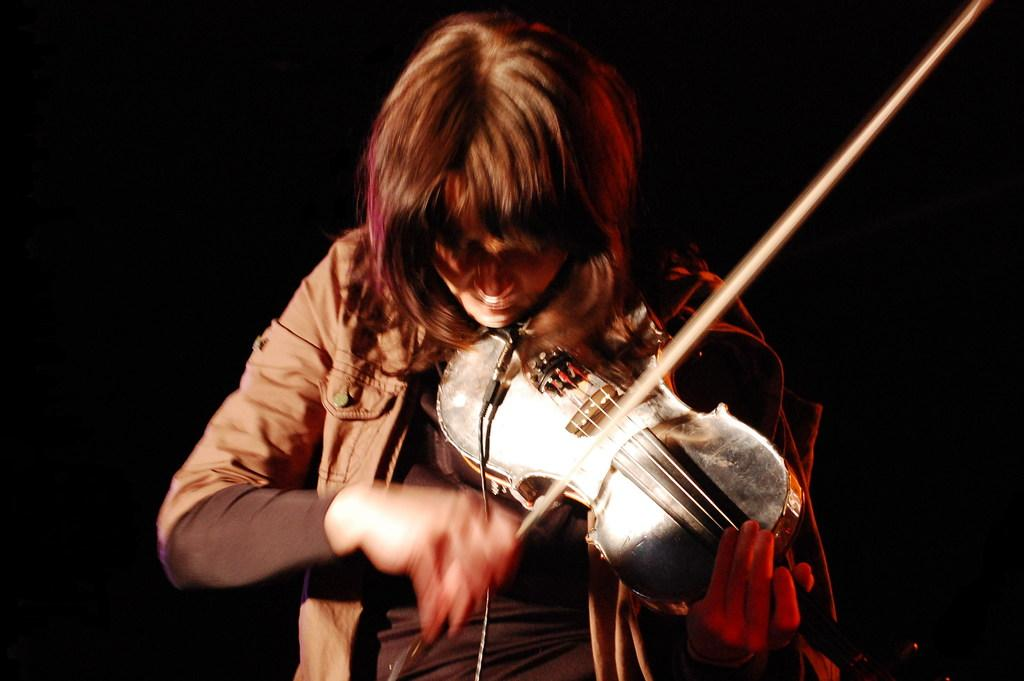What type of clothing is the person wearing in the image? The person is wearing a jacket. What object is the person holding in their hand? The person is holding a stick. What musical instrument is the person holding? The person is holding a violin. Where is the person's grandmother in the image? There is no mention of a grandmother in the image, so it cannot be determined if she is present or not. 